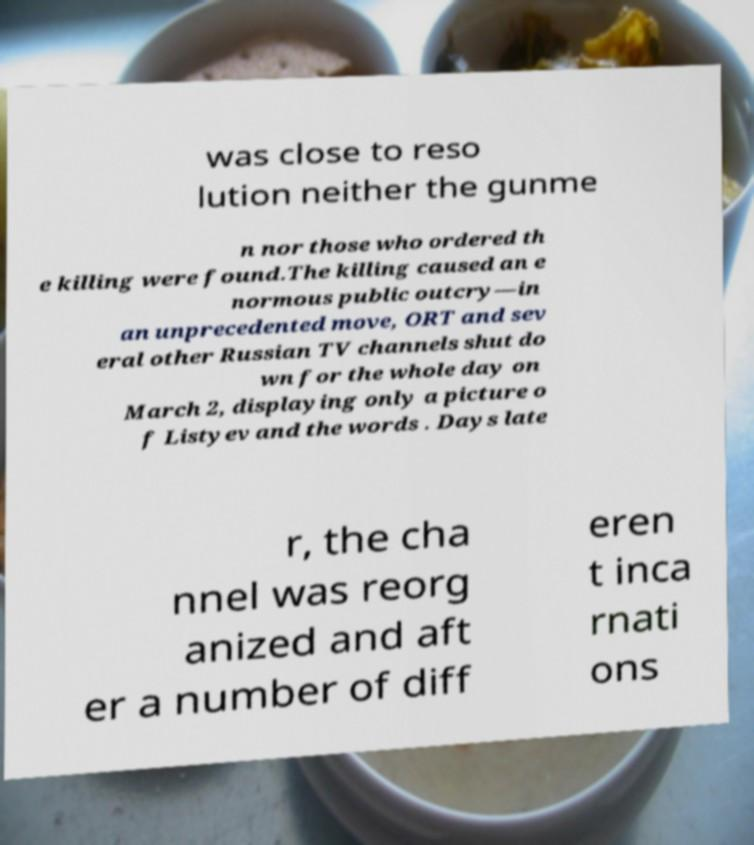Can you accurately transcribe the text from the provided image for me? was close to reso lution neither the gunme n nor those who ordered th e killing were found.The killing caused an e normous public outcry—in an unprecedented move, ORT and sev eral other Russian TV channels shut do wn for the whole day on March 2, displaying only a picture o f Listyev and the words . Days late r, the cha nnel was reorg anized and aft er a number of diff eren t inca rnati ons 